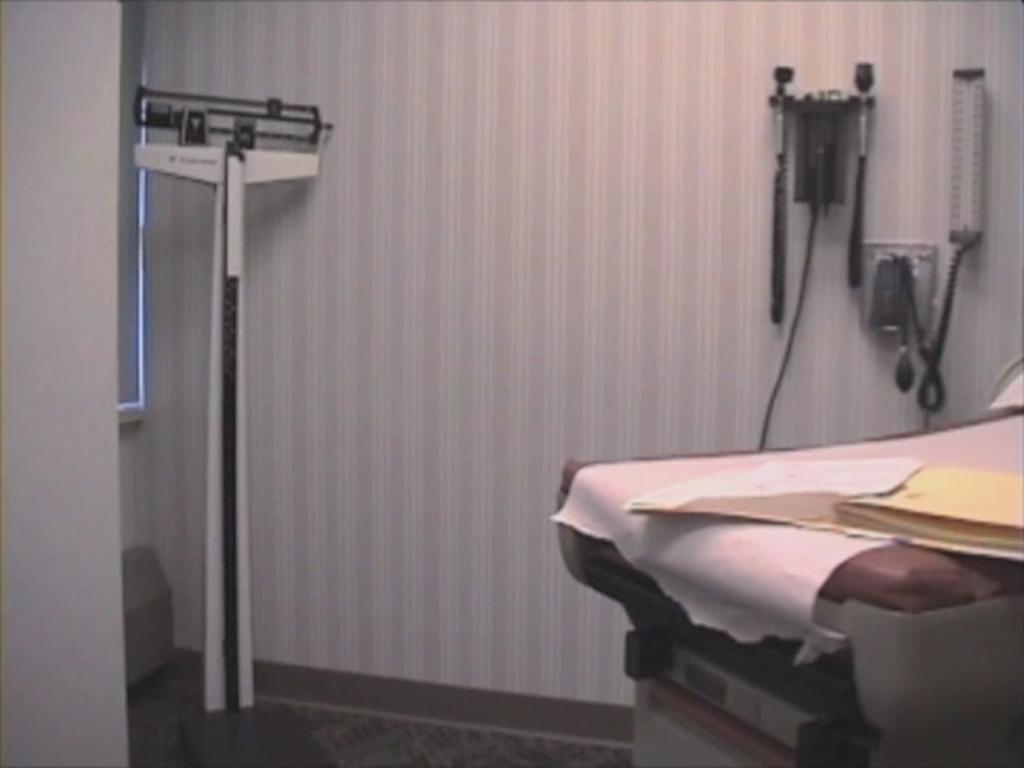Can you describe this image briefly? In this image in the front there is a bed and on the bed there is a file. In the background there is a stand and there are objects on the wall. On the left side in the background there is a window and there is a wall. 